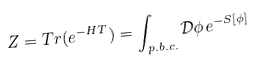Convert formula to latex. <formula><loc_0><loc_0><loc_500><loc_500>Z = T r ( e ^ { - H T } ) = \int _ { p . b . c . } \mathcal { D } \phi \, e ^ { - S [ \phi ] }</formula> 